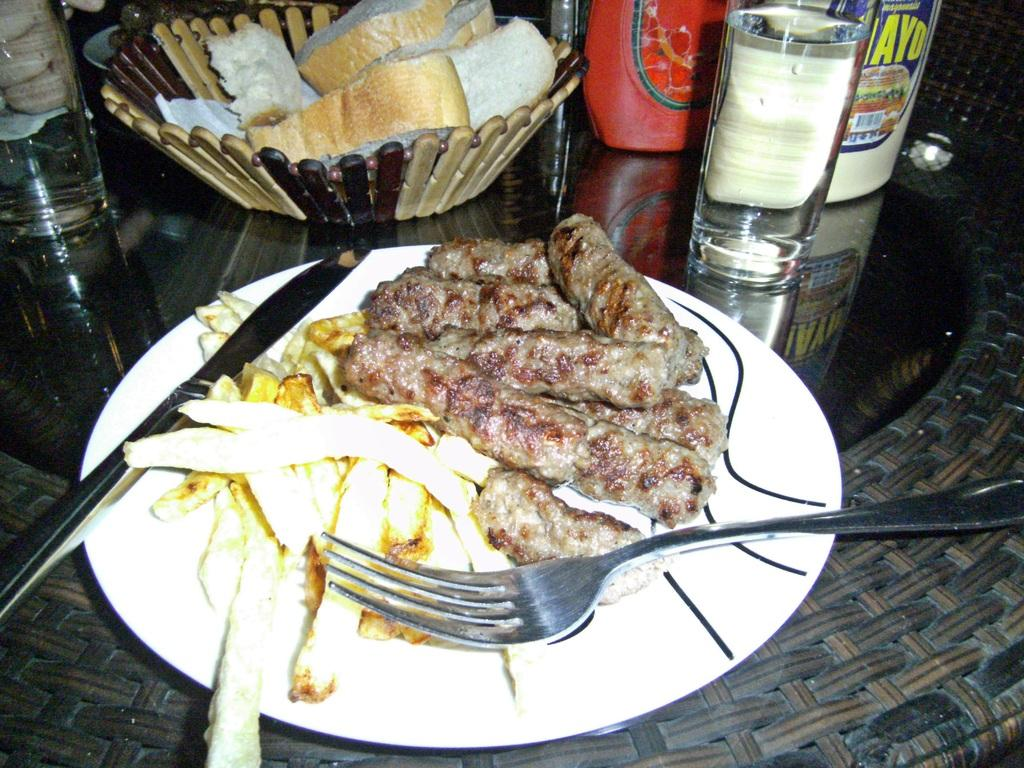What piece of furniture is present in the image? There is a table in the image. What is placed on the table? There is a plate, a fork, a knife, a basket, bread, glasses, and containers on the table. What type of food is present on the table? There is food placed on the table. What type of basketball game is being played in the image? There is no basketball game present in the image; it features a table with various items on it. What day of the week is depicted in the image? The image does not depict a specific day of the week; it only shows a table with various items on it. 